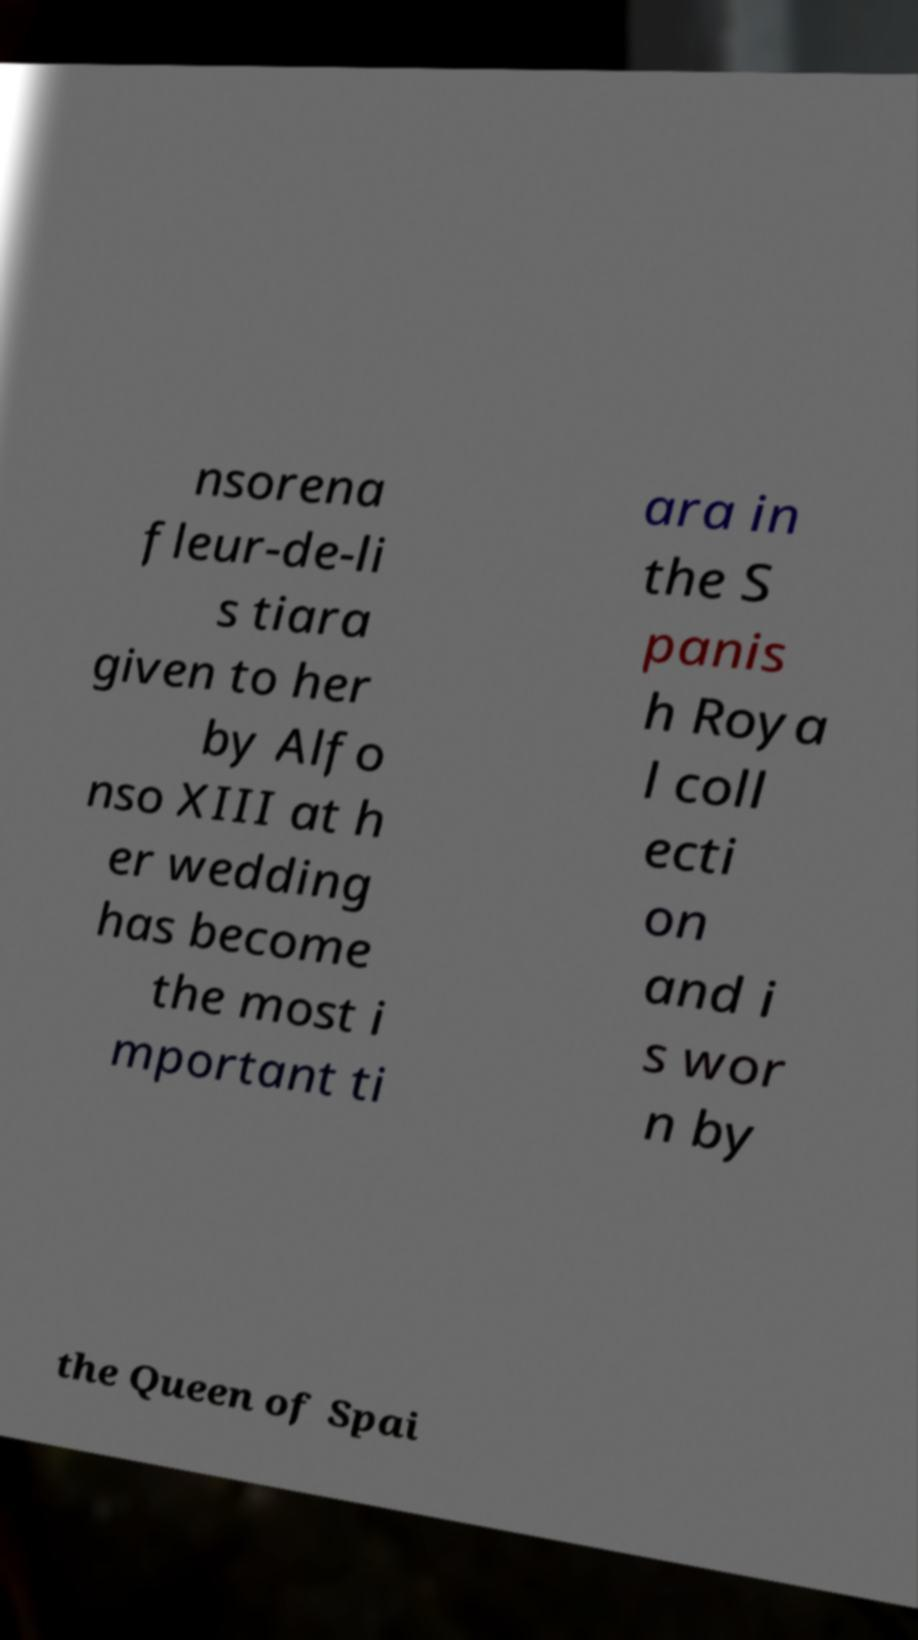Can you accurately transcribe the text from the provided image for me? nsorena fleur-de-li s tiara given to her by Alfo nso XIII at h er wedding has become the most i mportant ti ara in the S panis h Roya l coll ecti on and i s wor n by the Queen of Spai 